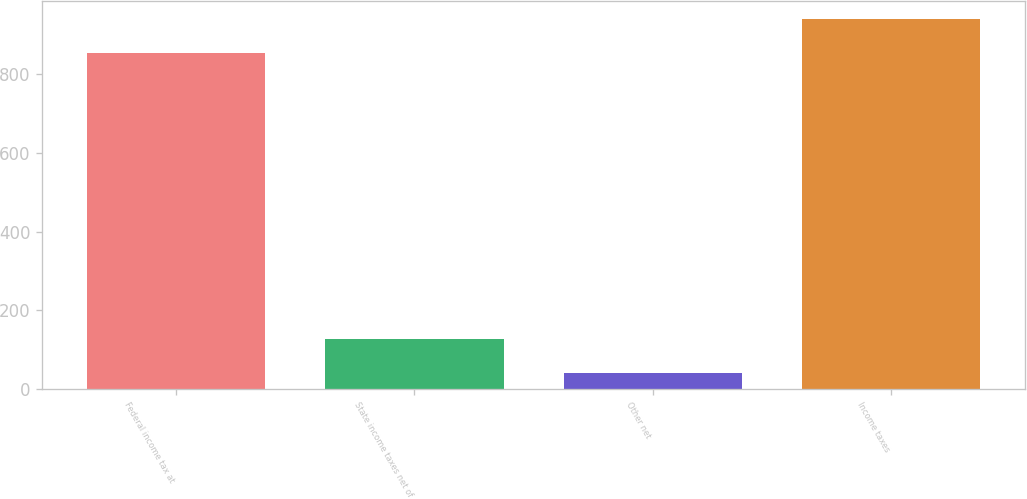Convert chart to OTSL. <chart><loc_0><loc_0><loc_500><loc_500><bar_chart><fcel>Federal income tax at<fcel>State income taxes net of<fcel>Other net<fcel>Income taxes<nl><fcel>855<fcel>125.5<fcel>41<fcel>939.5<nl></chart> 